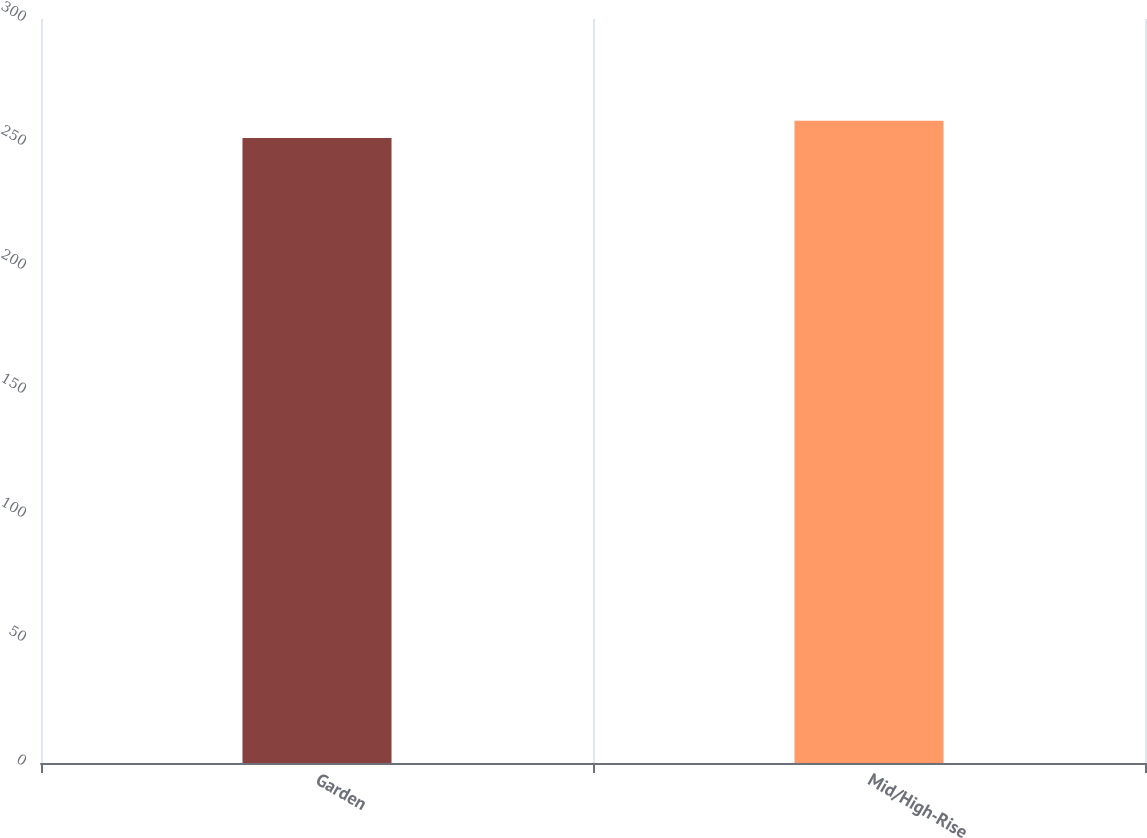<chart> <loc_0><loc_0><loc_500><loc_500><bar_chart><fcel>Garden<fcel>Mid/High-Rise<nl><fcel>252<fcel>259<nl></chart> 